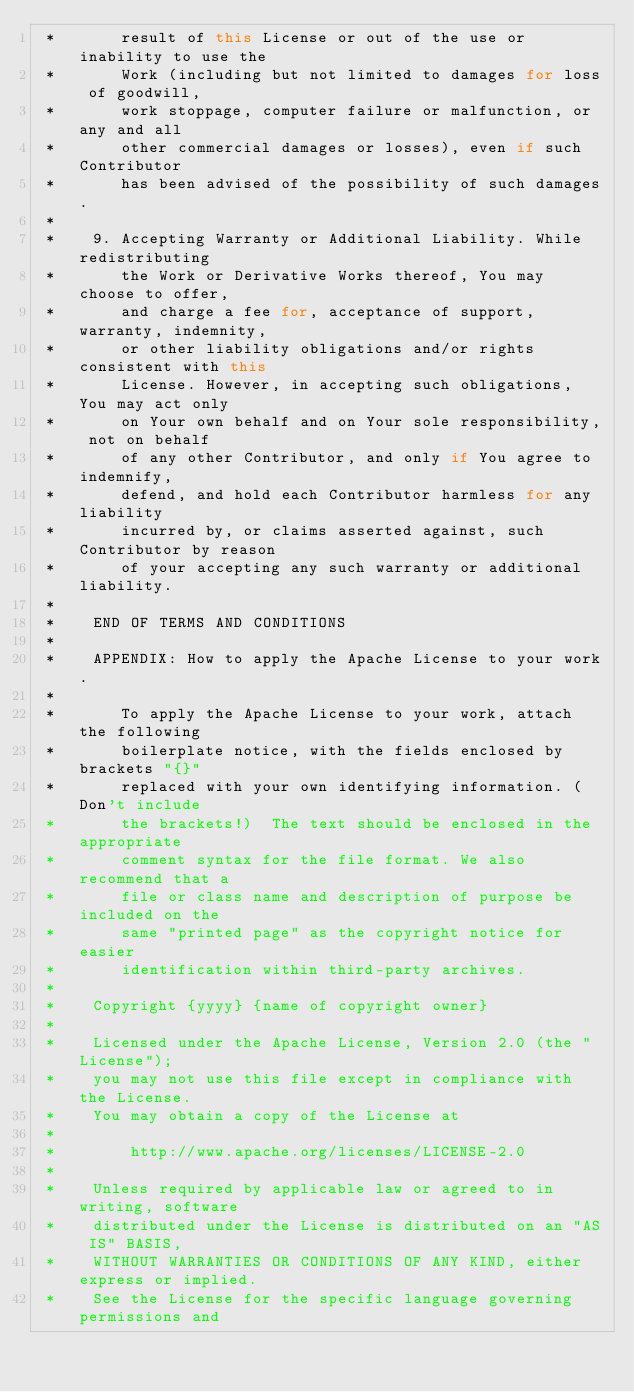Convert code to text. <code><loc_0><loc_0><loc_500><loc_500><_Java_> *       result of this License or out of the use or inability to use the
 *       Work (including but not limited to damages for loss of goodwill,
 *       work stoppage, computer failure or malfunction, or any and all
 *       other commercial damages or losses), even if such Contributor
 *       has been advised of the possibility of such damages.
 *
 *    9. Accepting Warranty or Additional Liability. While redistributing
 *       the Work or Derivative Works thereof, You may choose to offer,
 *       and charge a fee for, acceptance of support, warranty, indemnity,
 *       or other liability obligations and/or rights consistent with this
 *       License. However, in accepting such obligations, You may act only
 *       on Your own behalf and on Your sole responsibility, not on behalf
 *       of any other Contributor, and only if You agree to indemnify,
 *       defend, and hold each Contributor harmless for any liability
 *       incurred by, or claims asserted against, such Contributor by reason
 *       of your accepting any such warranty or additional liability.
 *
 *    END OF TERMS AND CONDITIONS
 *
 *    APPENDIX: How to apply the Apache License to your work.
 *
 *       To apply the Apache License to your work, attach the following
 *       boilerplate notice, with the fields enclosed by brackets "{}"
 *       replaced with your own identifying information. (Don't include
 *       the brackets!)  The text should be enclosed in the appropriate
 *       comment syntax for the file format. We also recommend that a
 *       file or class name and description of purpose be included on the
 *       same "printed page" as the copyright notice for easier
 *       identification within third-party archives.
 *
 *    Copyright {yyyy} {name of copyright owner}
 *
 *    Licensed under the Apache License, Version 2.0 (the "License");
 *    you may not use this file except in compliance with the License.
 *    You may obtain a copy of the License at
 *
 *        http://www.apache.org/licenses/LICENSE-2.0
 *
 *    Unless required by applicable law or agreed to in writing, software
 *    distributed under the License is distributed on an "AS IS" BASIS,
 *    WITHOUT WARRANTIES OR CONDITIONS OF ANY KIND, either express or implied.
 *    See the License for the specific language governing permissions and</code> 